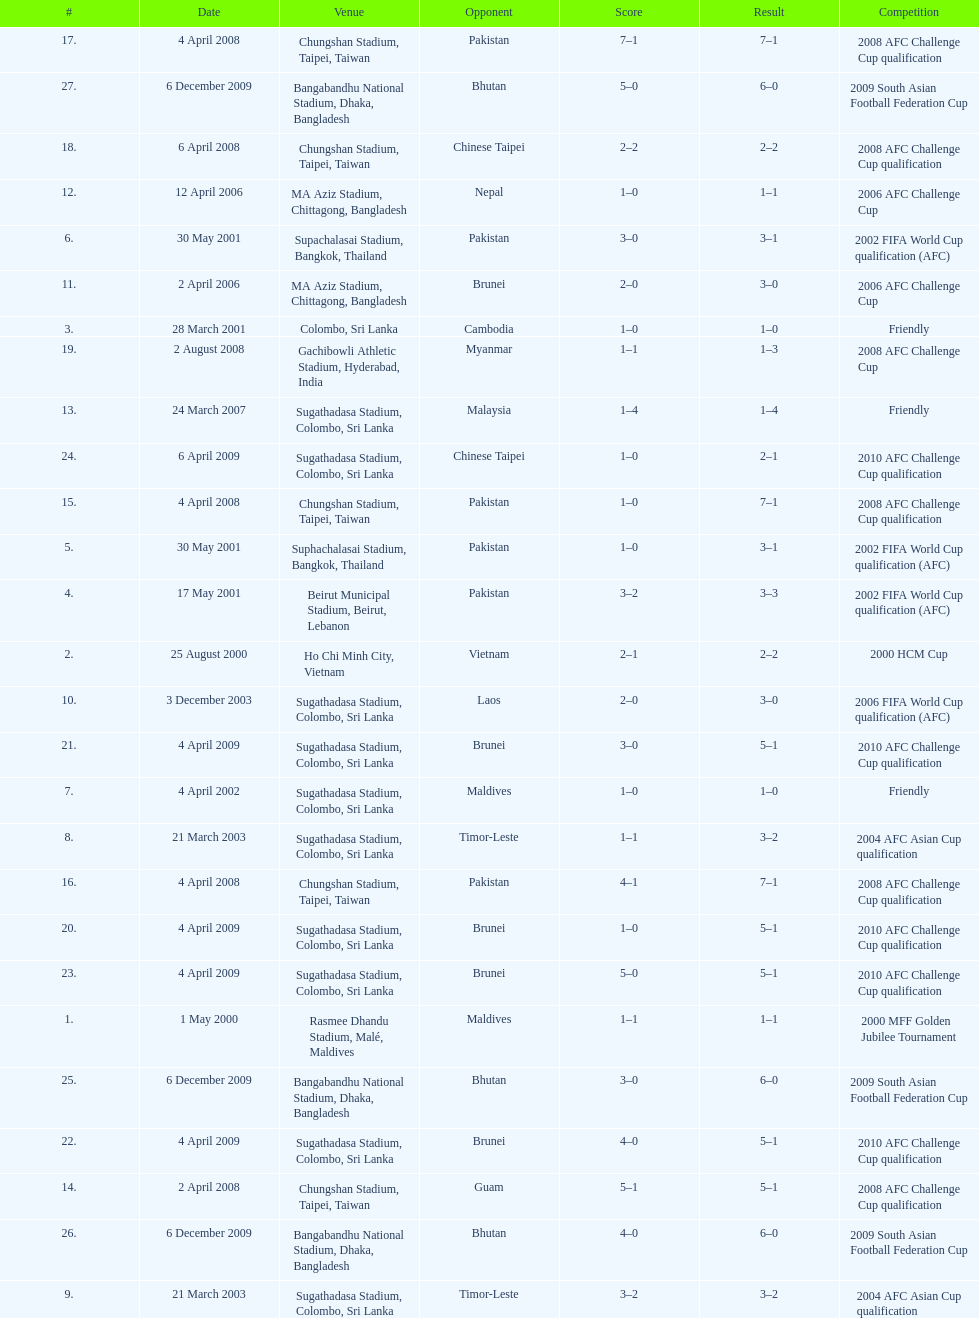Were more competitions played in april or december? April. Give me the full table as a dictionary. {'header': ['#', 'Date', 'Venue', 'Opponent', 'Score', 'Result', 'Competition'], 'rows': [['17.', '4 April 2008', 'Chungshan Stadium, Taipei, Taiwan', 'Pakistan', '7–1', '7–1', '2008 AFC Challenge Cup qualification'], ['27.', '6 December 2009', 'Bangabandhu National Stadium, Dhaka, Bangladesh', 'Bhutan', '5–0', '6–0', '2009 South Asian Football Federation Cup'], ['18.', '6 April 2008', 'Chungshan Stadium, Taipei, Taiwan', 'Chinese Taipei', '2–2', '2–2', '2008 AFC Challenge Cup qualification'], ['12.', '12 April 2006', 'MA Aziz Stadium, Chittagong, Bangladesh', 'Nepal', '1–0', '1–1', '2006 AFC Challenge Cup'], ['6.', '30 May 2001', 'Supachalasai Stadium, Bangkok, Thailand', 'Pakistan', '3–0', '3–1', '2002 FIFA World Cup qualification (AFC)'], ['11.', '2 April 2006', 'MA Aziz Stadium, Chittagong, Bangladesh', 'Brunei', '2–0', '3–0', '2006 AFC Challenge Cup'], ['3.', '28 March 2001', 'Colombo, Sri Lanka', 'Cambodia', '1–0', '1–0', 'Friendly'], ['19.', '2 August 2008', 'Gachibowli Athletic Stadium, Hyderabad, India', 'Myanmar', '1–1', '1–3', '2008 AFC Challenge Cup'], ['13.', '24 March 2007', 'Sugathadasa Stadium, Colombo, Sri Lanka', 'Malaysia', '1–4', '1–4', 'Friendly'], ['24.', '6 April 2009', 'Sugathadasa Stadium, Colombo, Sri Lanka', 'Chinese Taipei', '1–0', '2–1', '2010 AFC Challenge Cup qualification'], ['15.', '4 April 2008', 'Chungshan Stadium, Taipei, Taiwan', 'Pakistan', '1–0', '7–1', '2008 AFC Challenge Cup qualification'], ['5.', '30 May 2001', 'Suphachalasai Stadium, Bangkok, Thailand', 'Pakistan', '1–0', '3–1', '2002 FIFA World Cup qualification (AFC)'], ['4.', '17 May 2001', 'Beirut Municipal Stadium, Beirut, Lebanon', 'Pakistan', '3–2', '3–3', '2002 FIFA World Cup qualification (AFC)'], ['2.', '25 August 2000', 'Ho Chi Minh City, Vietnam', 'Vietnam', '2–1', '2–2', '2000 HCM Cup'], ['10.', '3 December 2003', 'Sugathadasa Stadium, Colombo, Sri Lanka', 'Laos', '2–0', '3–0', '2006 FIFA World Cup qualification (AFC)'], ['21.', '4 April 2009', 'Sugathadasa Stadium, Colombo, Sri Lanka', 'Brunei', '3–0', '5–1', '2010 AFC Challenge Cup qualification'], ['7.', '4 April 2002', 'Sugathadasa Stadium, Colombo, Sri Lanka', 'Maldives', '1–0', '1–0', 'Friendly'], ['8.', '21 March 2003', 'Sugathadasa Stadium, Colombo, Sri Lanka', 'Timor-Leste', '1–1', '3–2', '2004 AFC Asian Cup qualification'], ['16.', '4 April 2008', 'Chungshan Stadium, Taipei, Taiwan', 'Pakistan', '4–1', '7–1', '2008 AFC Challenge Cup qualification'], ['20.', '4 April 2009', 'Sugathadasa Stadium, Colombo, Sri Lanka', 'Brunei', '1–0', '5–1', '2010 AFC Challenge Cup qualification'], ['23.', '4 April 2009', 'Sugathadasa Stadium, Colombo, Sri Lanka', 'Brunei', '5–0', '5–1', '2010 AFC Challenge Cup qualification'], ['1.', '1 May 2000', 'Rasmee Dhandu Stadium, Malé, Maldives', 'Maldives', '1–1', '1–1', '2000 MFF Golden Jubilee Tournament'], ['25.', '6 December 2009', 'Bangabandhu National Stadium, Dhaka, Bangladesh', 'Bhutan', '3–0', '6–0', '2009 South Asian Football Federation Cup'], ['22.', '4 April 2009', 'Sugathadasa Stadium, Colombo, Sri Lanka', 'Brunei', '4–0', '5–1', '2010 AFC Challenge Cup qualification'], ['14.', '2 April 2008', 'Chungshan Stadium, Taipei, Taiwan', 'Guam', '5–1', '5–1', '2008 AFC Challenge Cup qualification'], ['26.', '6 December 2009', 'Bangabandhu National Stadium, Dhaka, Bangladesh', 'Bhutan', '4–0', '6–0', '2009 South Asian Football Federation Cup'], ['9.', '21 March 2003', 'Sugathadasa Stadium, Colombo, Sri Lanka', 'Timor-Leste', '3–2', '3–2', '2004 AFC Asian Cup qualification']]} 